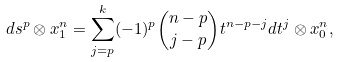Convert formula to latex. <formula><loc_0><loc_0><loc_500><loc_500>d s ^ { p } \otimes x _ { 1 } ^ { n } = \sum _ { j = p } ^ { k } ( - 1 ) ^ { p } \binom { n - p } { j - p } t ^ { n - p - j } d t ^ { j } \otimes x _ { 0 } ^ { n } ,</formula> 